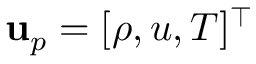<formula> <loc_0><loc_0><loc_500><loc_500>u _ { p } = [ \rho , u , T ] ^ { \top }</formula> 